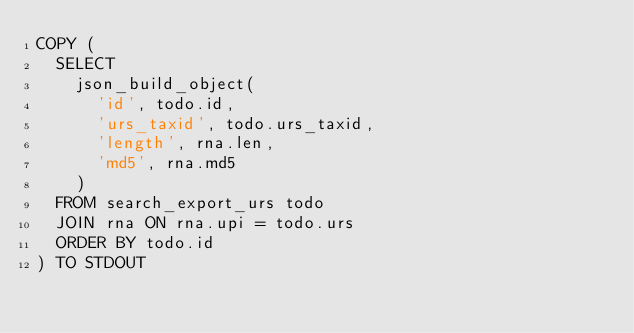<code> <loc_0><loc_0><loc_500><loc_500><_SQL_>COPY (
  SELECT
    json_build_object(
      'id', todo.id,
      'urs_taxid', todo.urs_taxid,
      'length', rna.len,
      'md5', rna.md5
    )
  FROM search_export_urs todo
  JOIN rna ON rna.upi = todo.urs
  ORDER BY todo.id
) TO STDOUT
</code> 